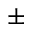Convert formula to latex. <formula><loc_0><loc_0><loc_500><loc_500>\pm</formula> 